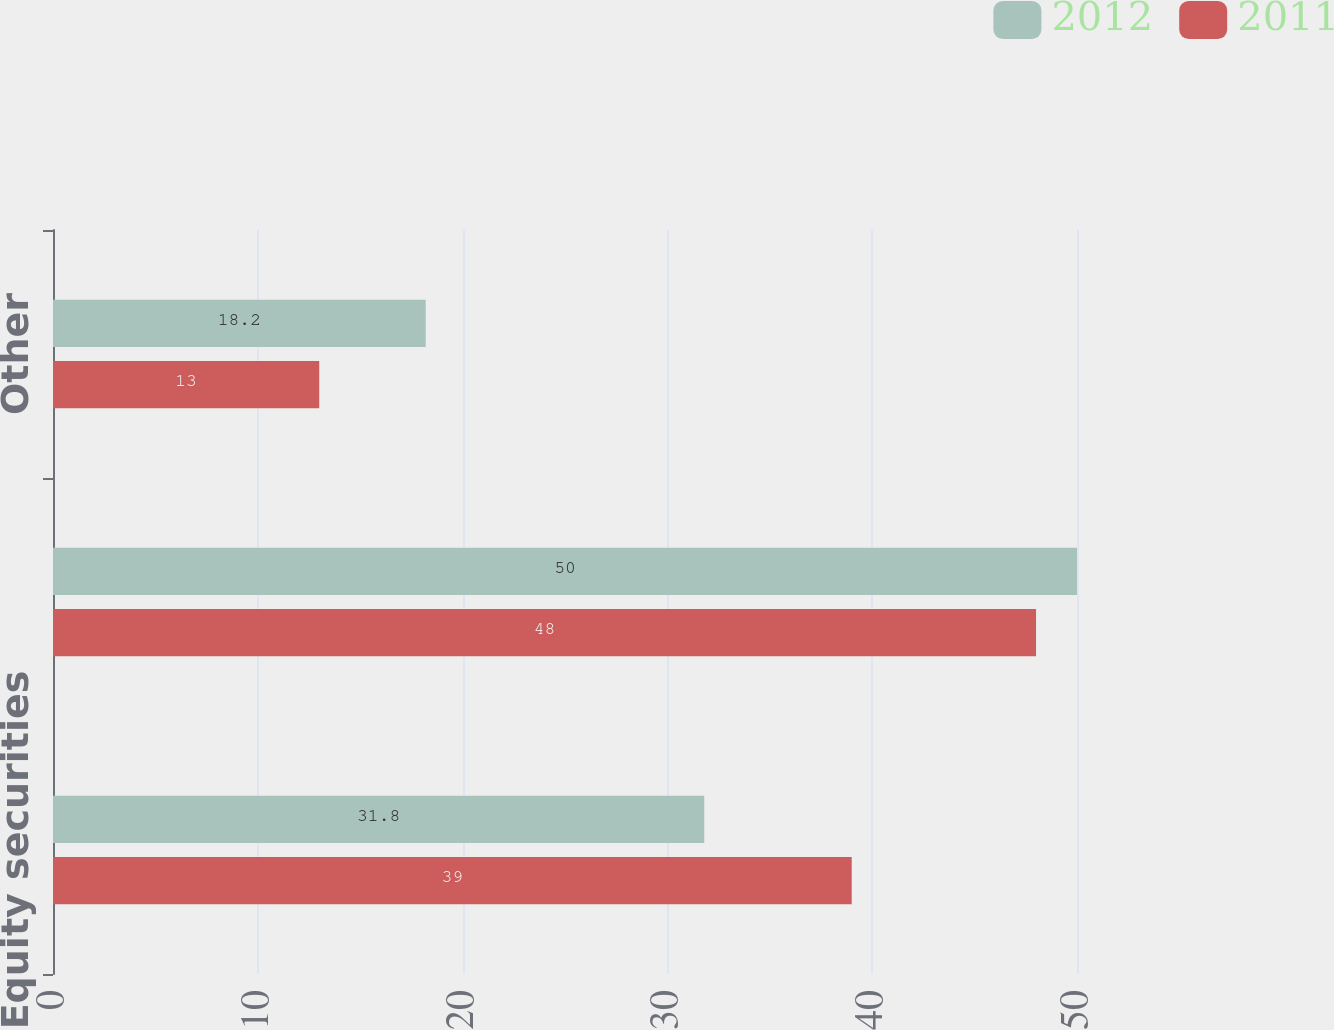Convert chart to OTSL. <chart><loc_0><loc_0><loc_500><loc_500><stacked_bar_chart><ecel><fcel>Equity securities<fcel>Debt securities<fcel>Other<nl><fcel>2012<fcel>31.8<fcel>50<fcel>18.2<nl><fcel>2011<fcel>39<fcel>48<fcel>13<nl></chart> 